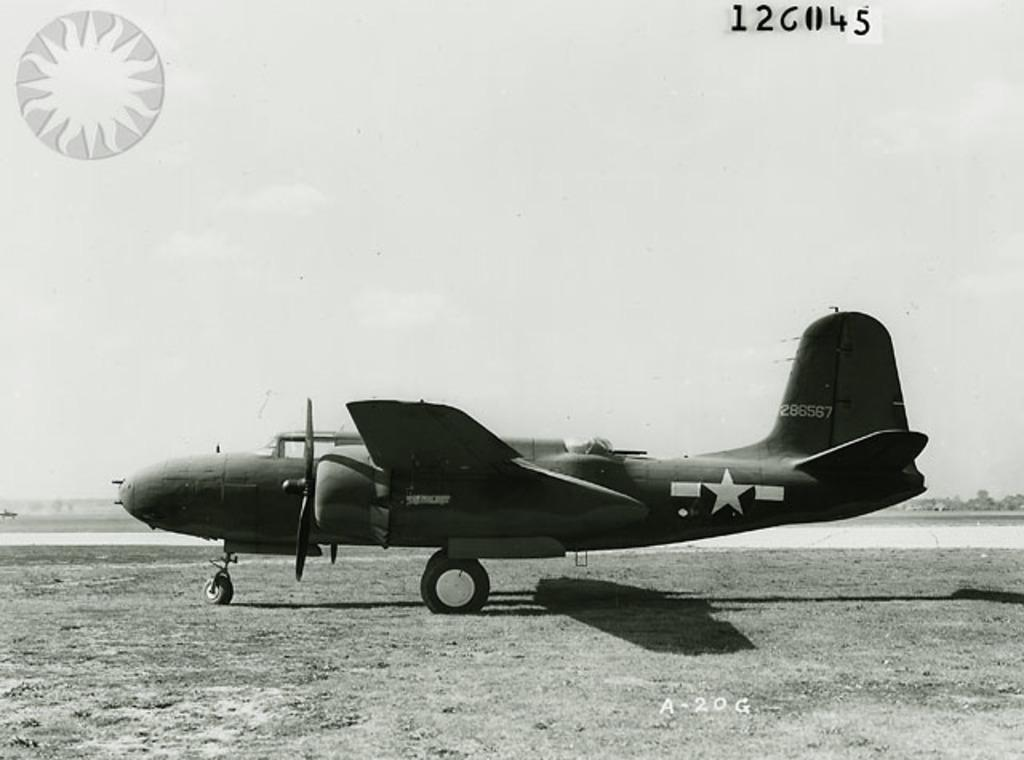<image>
Offer a succinct explanation of the picture presented. A very old prop plane has the tail number 286567. 